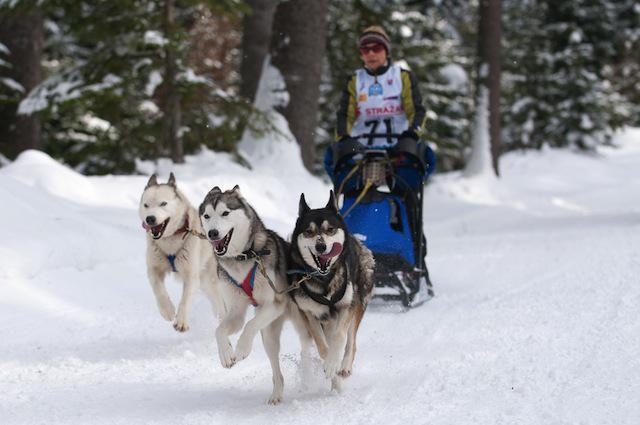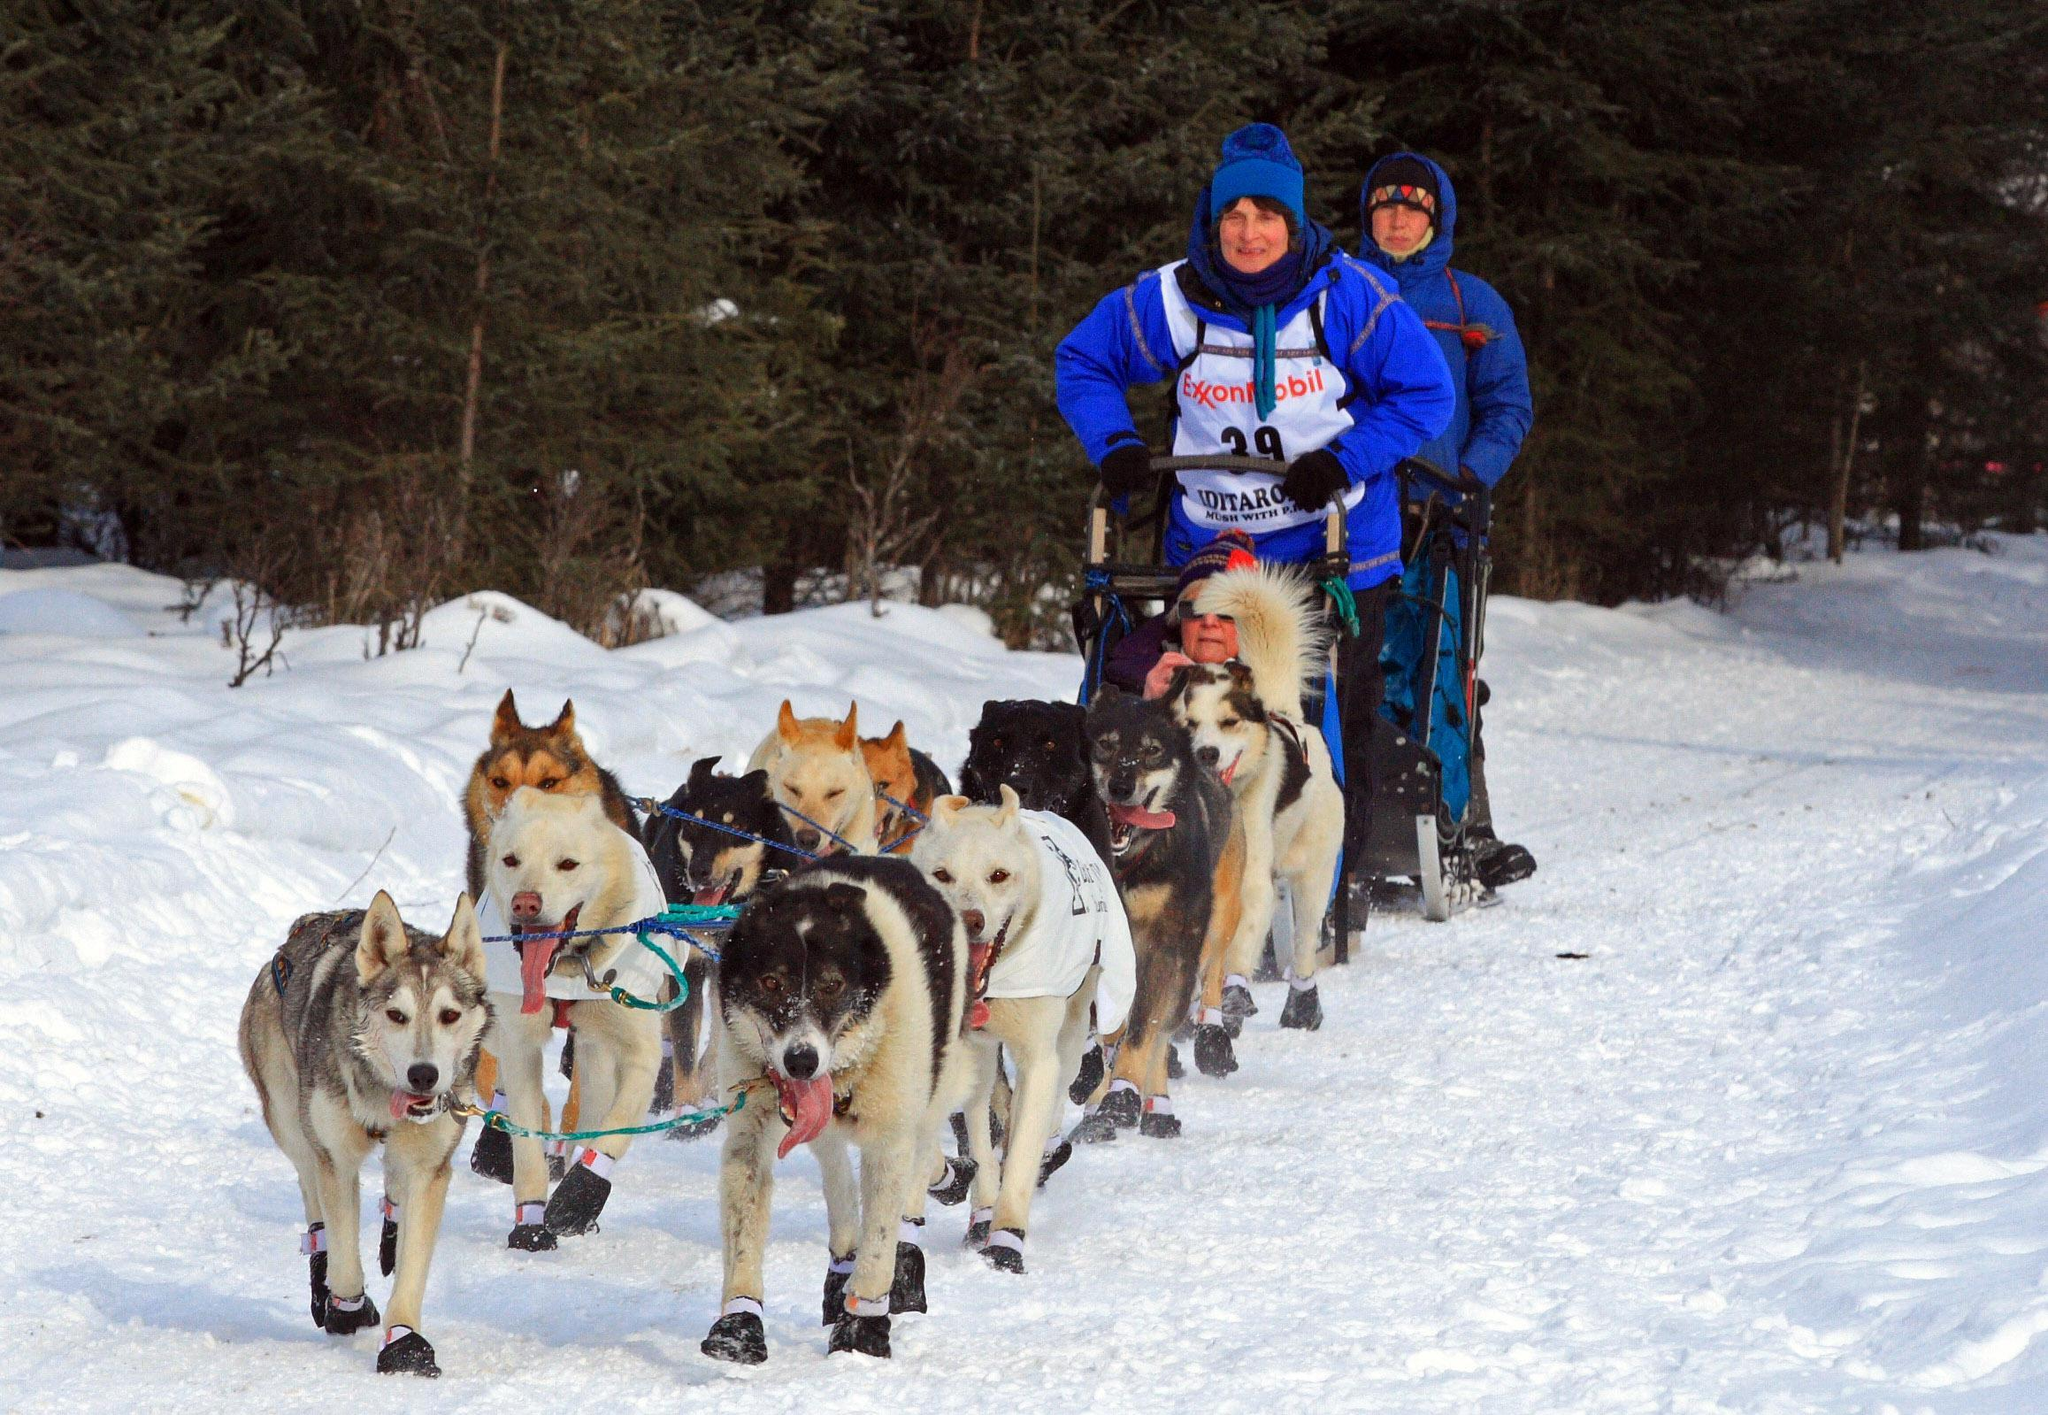The first image is the image on the left, the second image is the image on the right. For the images displayed, is the sentence "A person wearing a blue jacket is driving the sled in the photo on the right.." factually correct? Answer yes or no. Yes. The first image is the image on the left, the second image is the image on the right. For the images displayed, is the sentence "One of the pictures shows more than one human being pulled by the dogs." factually correct? Answer yes or no. Yes. The first image is the image on the left, the second image is the image on the right. Considering the images on both sides, is "There are four dogs on the left image" valid? Answer yes or no. No. 